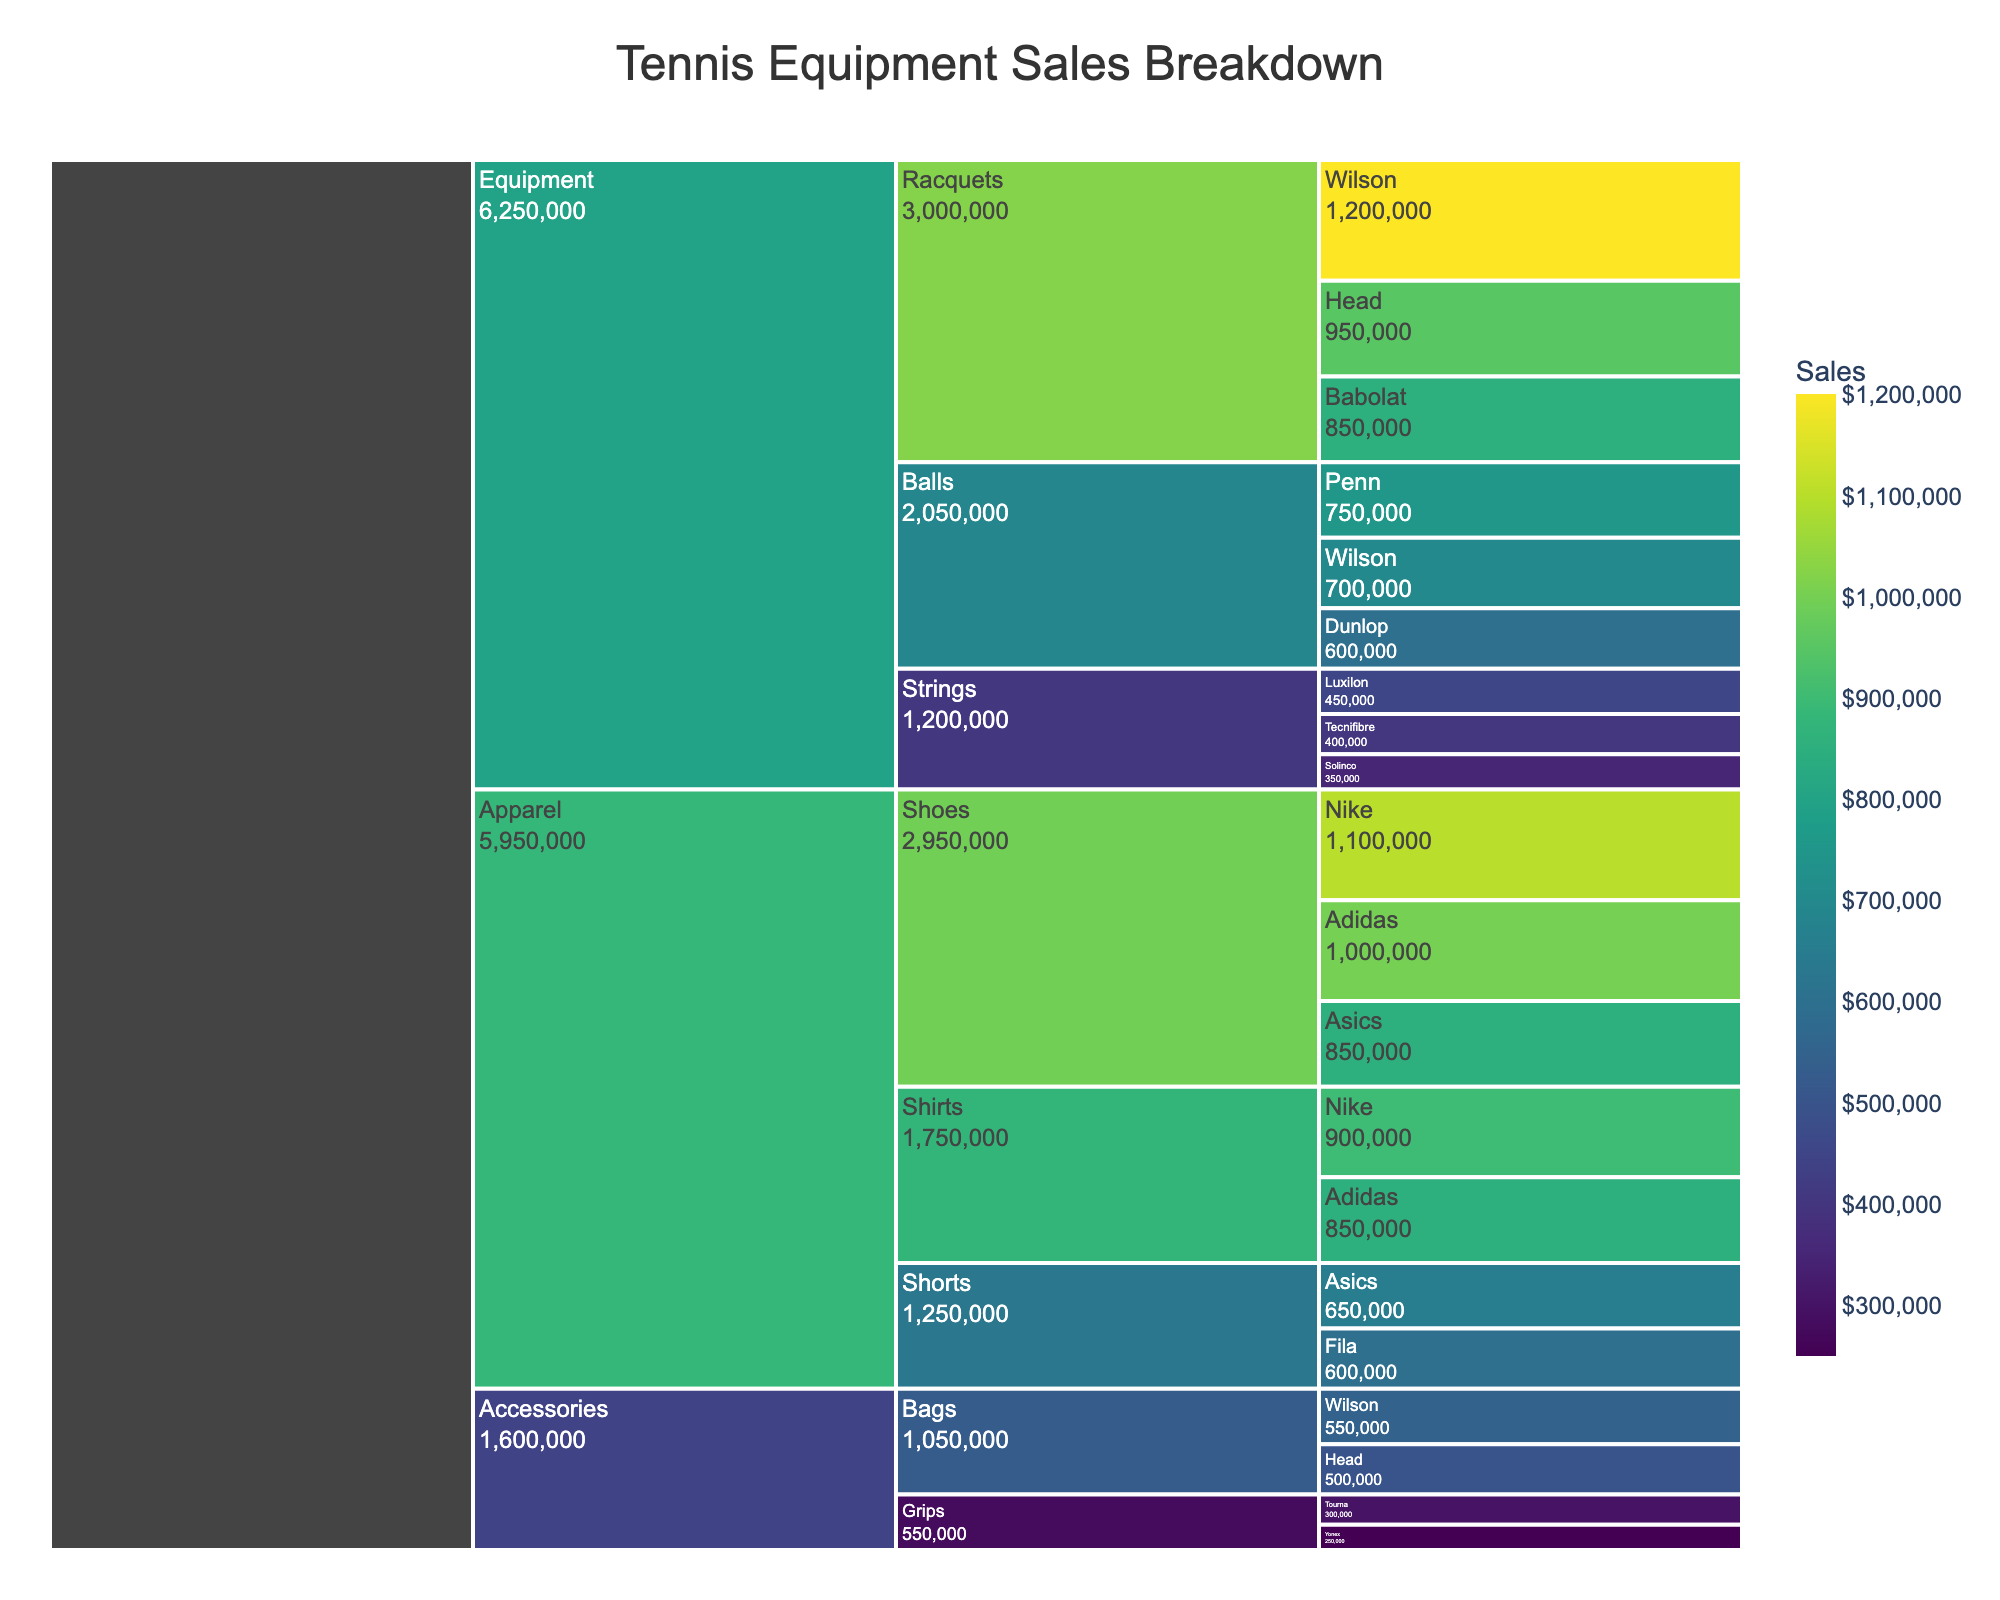What's the title of the chart? The title is located at the top center of the chart, showing the main theme. It reads "Tennis Equipment Sales Breakdown".
Answer: Tennis Equipment Sales Breakdown Which category has the highest total sales? Sum the sales of each category: Equipment (1200000+950000+850000+750000+700000+600000+450000+400000+350000), Apparel (900000+850000+650000+600000+1100000+1000000+850000), Accessories (550000+500000+300000+250000). Equipment has the highest total sales.
Answer: Equipment What are the sales figures for Nike shoes and Wilson racquets combined? Nike shoes sales ($1,100,000) and Wilson racquets sales ($1,200,000) combined total sales are $1,100,000 + $1,200,000.
Answer: $2,300,000 Which brand has the highest combined sales in all categories? Sum sales for each brand across all categories: Wilson, for instance, has sales from racquets, balls, and bags. Repeating this for all brands, we find that Wilson has the highest combined sales.
Answer: Wilson Compare the sales of Wilson racquets and Head racquets. Which one is greater and by how much? Wilson racquets have sales of $1,200,000 while Head racquets have sales of $950,000. The difference is $1,200,000 - $950,000.
Answer: Wilson by $250,000 Which subcategory has the lowest sales within the Equipment category? Compare the total sales of Racquets (sum of all brands), Balls (sum of all brands), and Strings (sum of all brands). Strings has the lowest sales among them.
Answer: Strings How do the sales figures for Nike apparel compare between Shirts and Shoes? Look at the sales figures of Nike under Shirts ($900,000) and Shoes ($1,100,000) subcategories. Shoes have higher sales.
Answer: Nike Shoes > Nike Shirts What's the total sales of all brands under the Balls subcategory? Sum the sales of Penn, Wilson, and Dunlop under the Balls subcategory. $750,000 + $700,000 + $600,000.
Answer: $2,050,000 What proportion of the total shoes sales are Adidas shoes? First, find the total sales of all shoes: Nike ($1,100,000), Adidas ($1,000,000), Asics ($850,000). Then, divide Adidas sales by the total sales. $1,000,000 / ($1,100,000 + $1,000,000 + $850,000).
Answer: Approximately 33.3% Identify the top-performing brand in the Accessories category and provide the sales figure. Compare the sales of brands under Accessories: Wilson ($550,000), Head ($500,000), Tourna ($300,000), Yonex ($250,000). Wilson has the highest sales.
Answer: Wilson with $550,000 